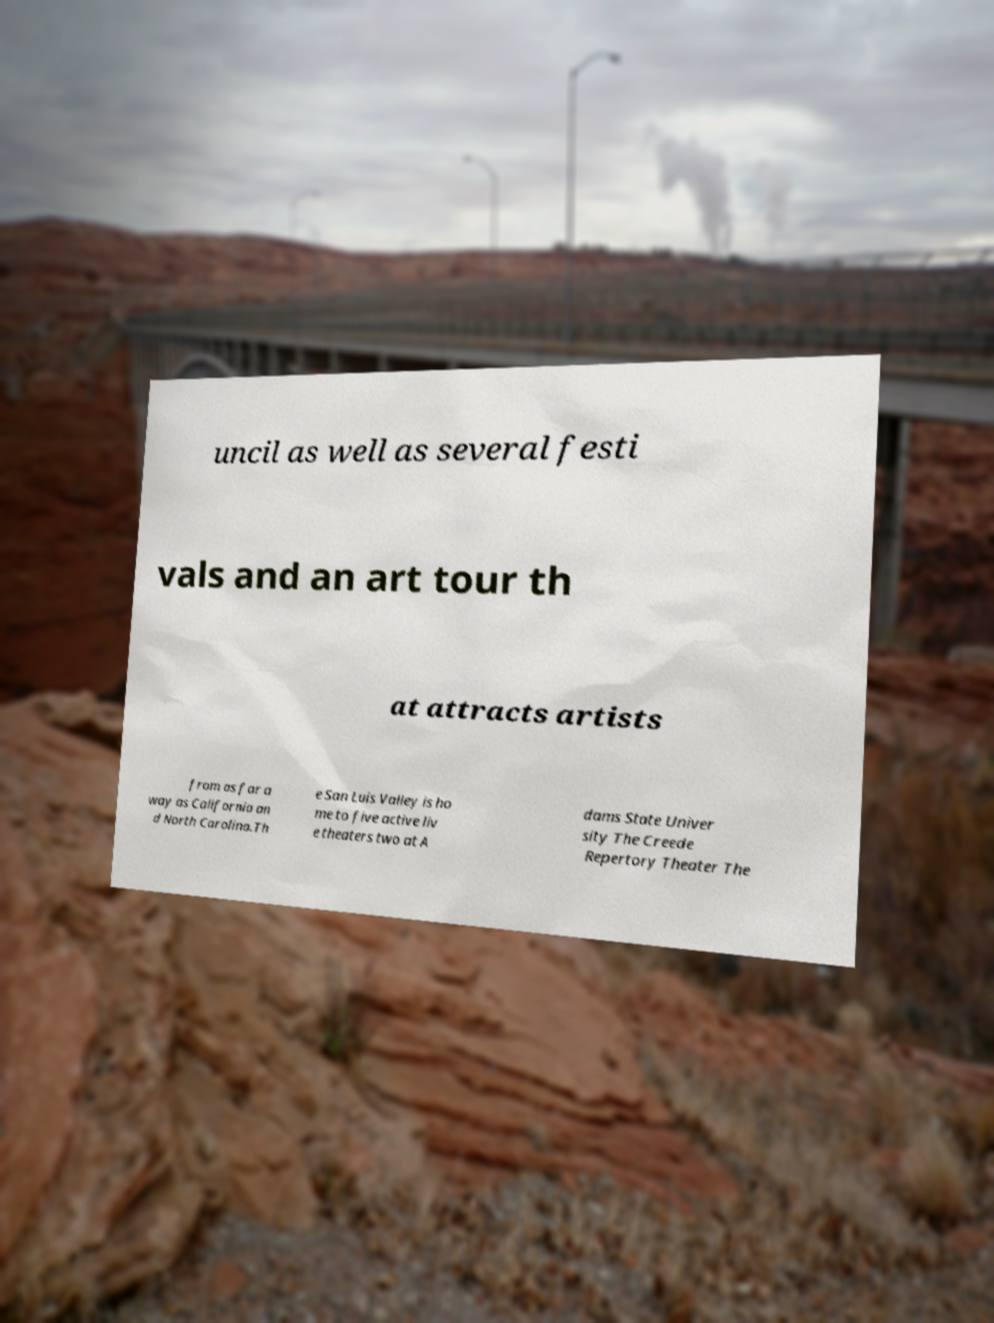Could you assist in decoding the text presented in this image and type it out clearly? uncil as well as several festi vals and an art tour th at attracts artists from as far a way as California an d North Carolina.Th e San Luis Valley is ho me to five active liv e theaters two at A dams State Univer sity The Creede Repertory Theater The 